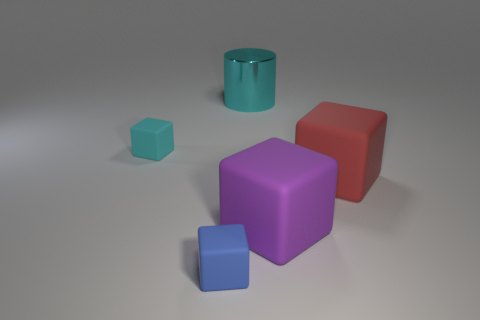Subtract all cyan cubes. How many cubes are left? 3 Add 1 big purple rubber objects. How many objects exist? 6 Subtract all green blocks. Subtract all blue cylinders. How many blocks are left? 4 Subtract all cubes. How many objects are left? 1 Add 1 cyan cubes. How many cyan cubes exist? 2 Subtract 0 purple balls. How many objects are left? 5 Subtract all blue rubber cylinders. Subtract all big metal things. How many objects are left? 4 Add 1 big red things. How many big red things are left? 2 